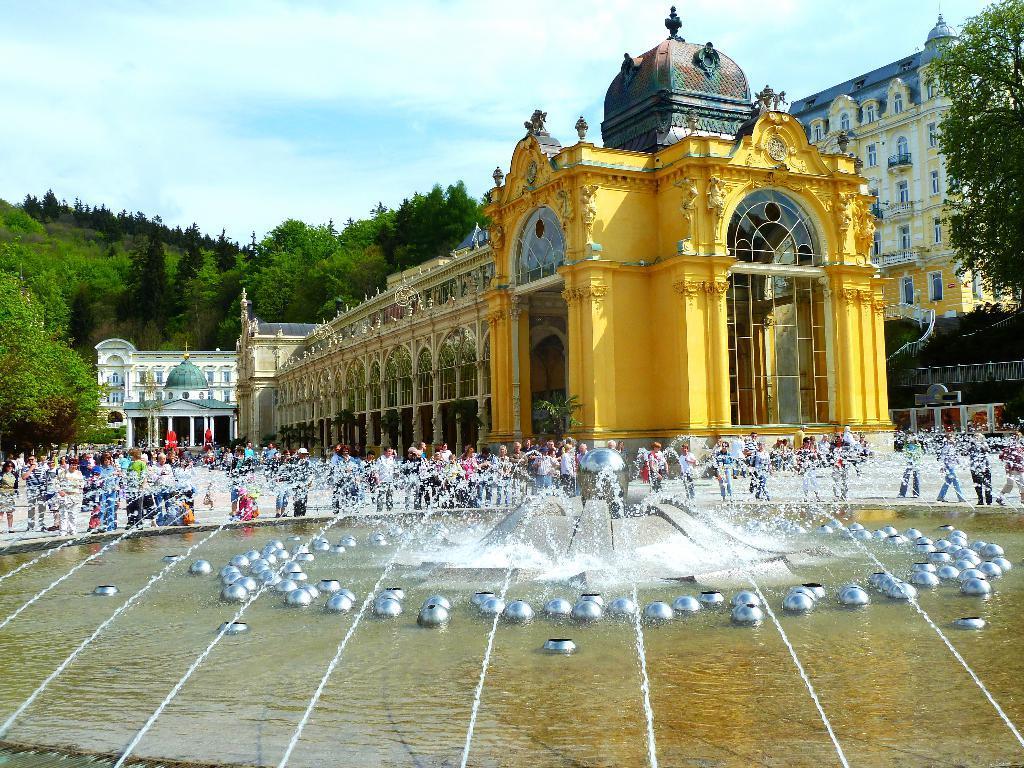Could you give a brief overview of what you see in this image? In this picture we can see water fountain and metal objects. There are people and we can see buildings, railing and trees. In the background of the image we can see the sky with clouds. 